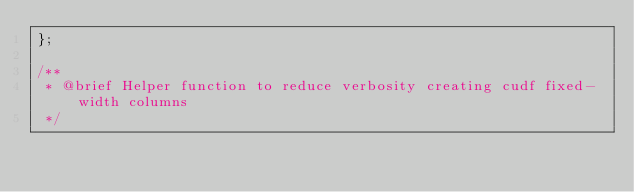Convert code to text. <code><loc_0><loc_0><loc_500><loc_500><_Cuda_>};

/**
 * @brief Helper function to reduce verbosity creating cudf fixed-width columns
 */</code> 